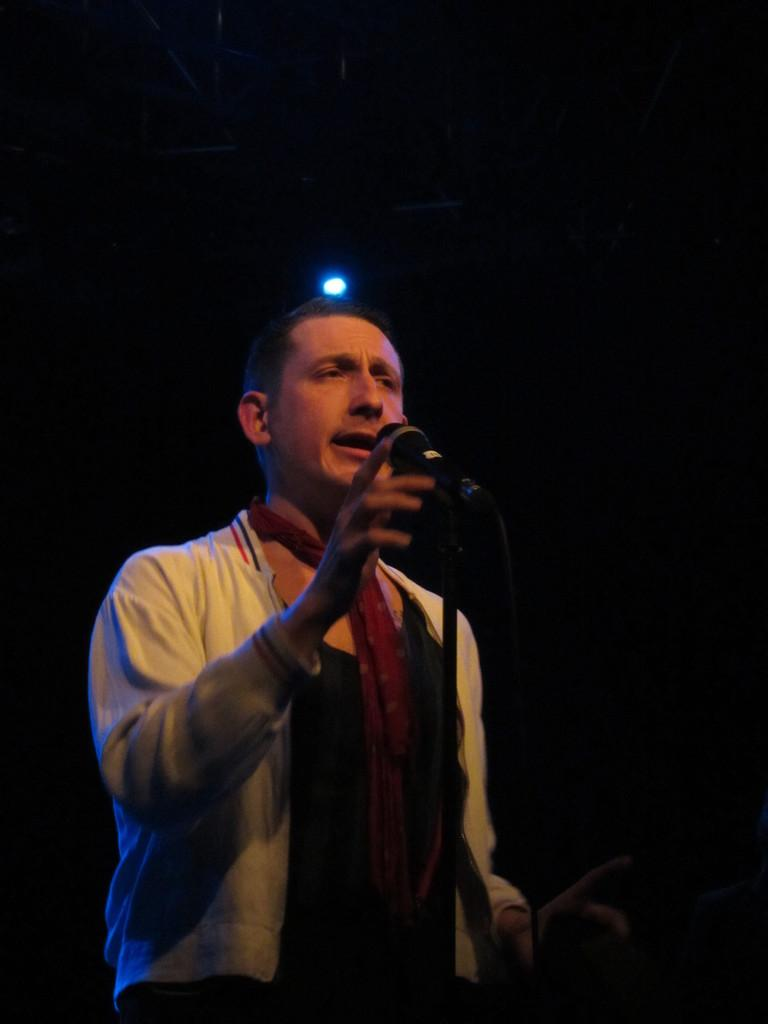Who is in the image? There is a man in the image. What object is in the image that is typically used for photography or videography? There is a tripod in the image. What is attached to the tripod? A microphone is present on the tripod. How would you describe the lighting conditions in the image? The background of the image appears to be dark, but there is a light visible in the background. What type of ear is visible on the man in the image? There is no ear visible on the man in the image. What thrill can be experienced by the man in the image? There is no indication of a thrill or any specific activity being experienced by the man in the image. 